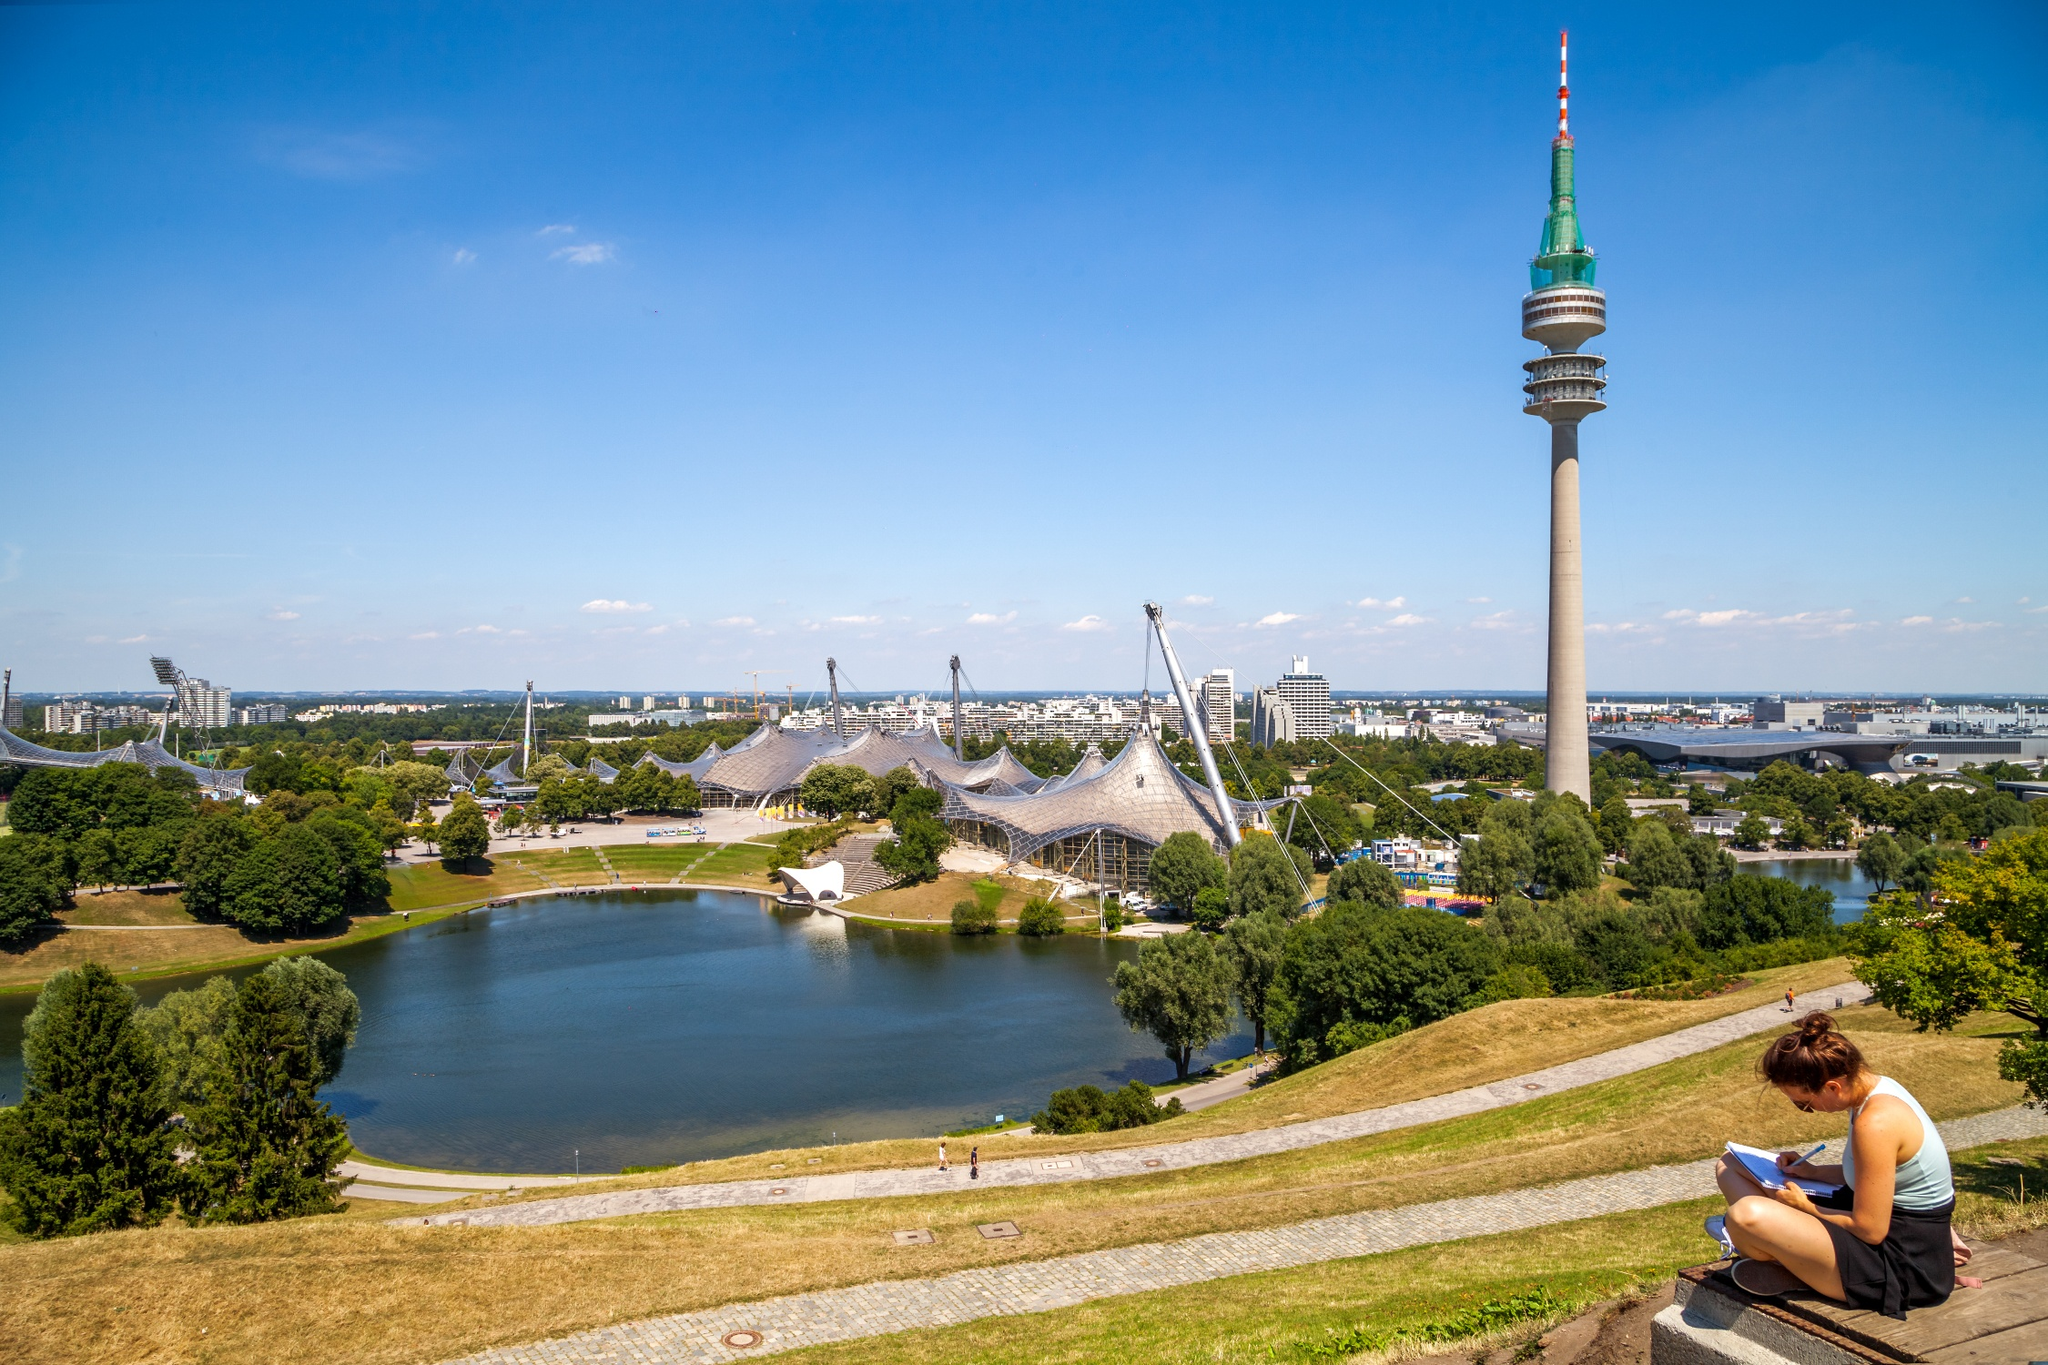What's happening in the scene? This image beautifully showcases the Olympic Park in Munich, Germany. The vantage point provides a panoramic vista of the park enveloped in lush greenery with a serene, reflective lake. Towering in the background is the Olympic Tower, recognizable by its distinct red and white striped top. The unique and iconic tent-like roof structure of the Olympic Stadium is also prominently visible. Adding a human element to the tranquil scenery, a person is seen peacefully reading a book while seated on a bench, immersed in the calm surroundings. 